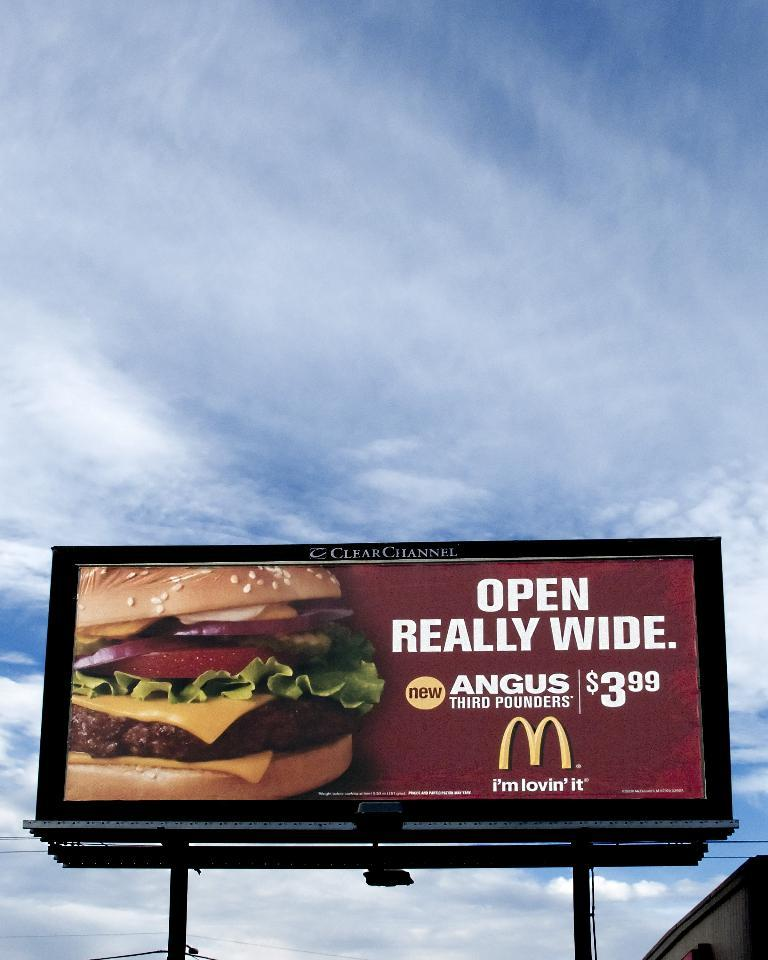<image>
Write a terse but informative summary of the picture. A McDonald's sign tells people to open really wide. 